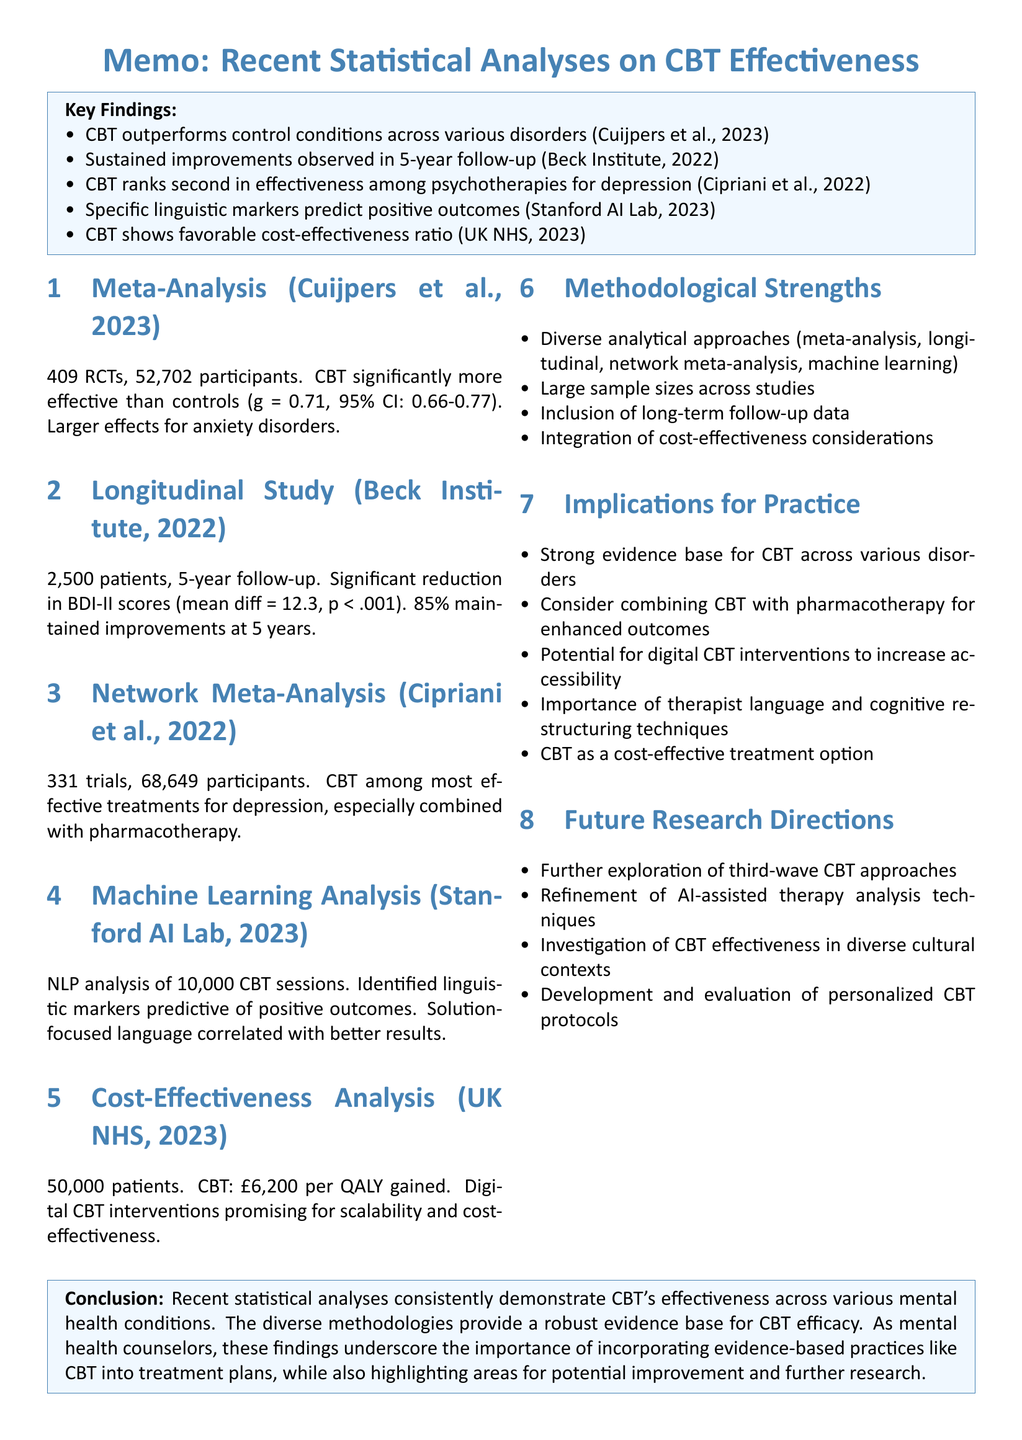what is the sample size of the meta-analysis by Cuijpers et al.? The sample size referenced in the meta-analysis is the total number of participants included, which is stated as 52,702.
Answer: 52,702 what was the mean difference in BDI-II scores according to the Longitudinal Study? The document specifies a mean difference of 12.3 points, indicating the significant reduction in depressive symptoms measured by BDI-II.
Answer: 12.3 points which therapy ranked second in effectiveness among psychotherapies? The network meta-analysis indicates that CBT was ranked second in effectiveness, as reported by Cipriani et al.
Answer: CBT what methodology was used in the Machine Learning Analysis? The document mentions that natural language processing techniques, including sentiment analysis and topic modeling, were used in the analysis of therapy sessions.
Answer: NLP techniques what percentage of participants maintained improvements at the 5-year follow-up? The Longitudinal Study notes that 85% of participants maintained improvements at the follow-up, demonstrating sustainability of outcomes.
Answer: 85% what is the cost-effectiveness ratio for CBT as reported by the UK NHS? The cost-effectiveness analysis conducted by the NHS found a favorable ratio for CBT, specified as £6,200 per QALY gained.
Answer: £6,200 per QALY gained what is the main implication for practice regarding digital CBT interventions? The findings indicate that digital CBT interventions show particular promise in terms of scalability and cost-effectiveness, suggesting they could be beneficial in practice.
Answer: scalability and cost-effectiveness what are the future research directions mentioned in the document? The document lists several areas for future research, including exploring third-wave CBT approaches and investigating CBT effectiveness in diverse cultural contexts.
Answer: third-wave CBT approaches, cultural contexts 